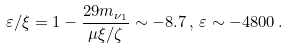Convert formula to latex. <formula><loc_0><loc_0><loc_500><loc_500>\varepsilon / \xi = 1 - \frac { 2 9 m _ { \nu _ { 1 } } } { \mu \xi / \zeta } \sim - 8 . 7 \, , \, \varepsilon \sim - 4 8 0 0 \, .</formula> 